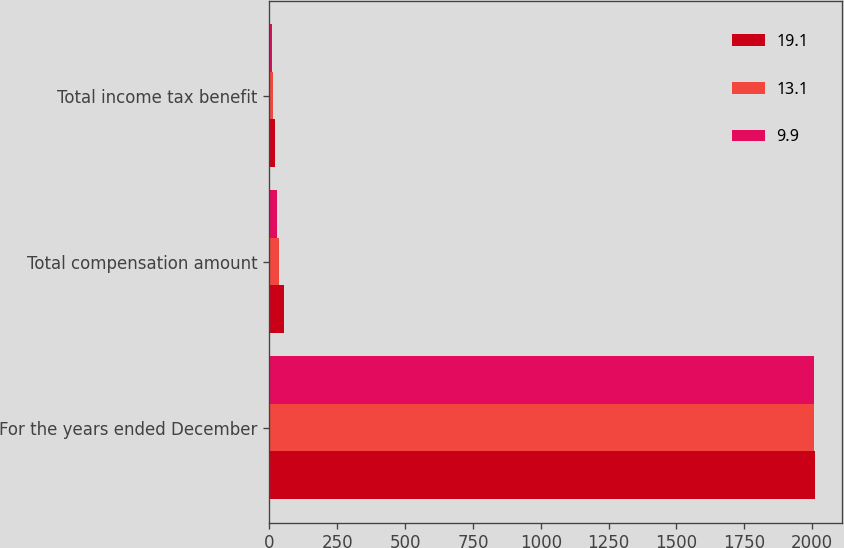Convert chart to OTSL. <chart><loc_0><loc_0><loc_500><loc_500><stacked_bar_chart><ecel><fcel>For the years ended December<fcel>Total compensation amount<fcel>Total income tax benefit<nl><fcel>19.1<fcel>2009<fcel>53.8<fcel>19.1<nl><fcel>13.1<fcel>2008<fcel>36.3<fcel>13.1<nl><fcel>9.9<fcel>2007<fcel>28.5<fcel>9.9<nl></chart> 